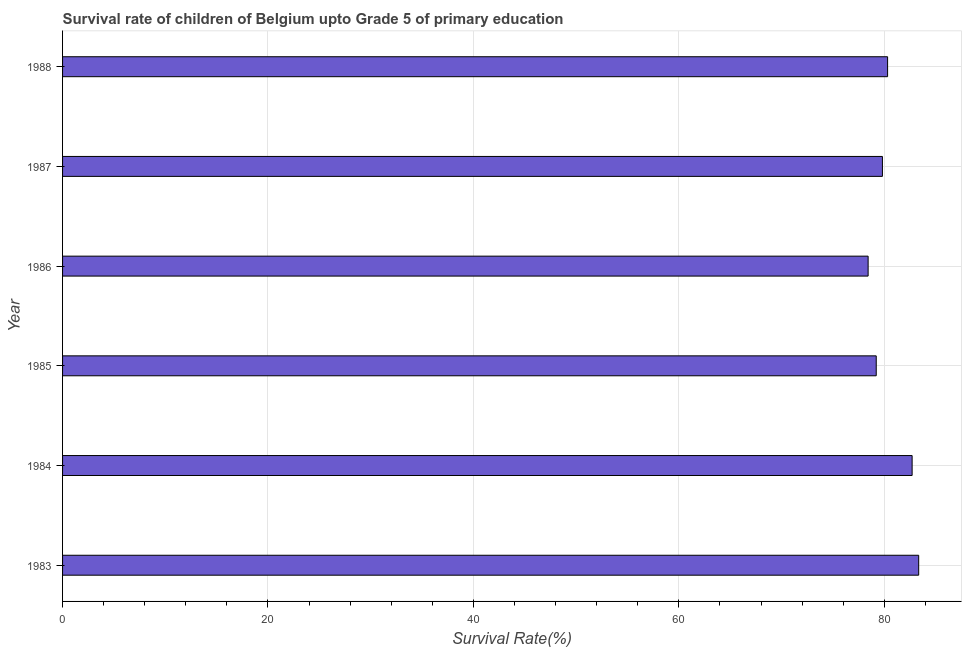Does the graph contain any zero values?
Keep it short and to the point. No. Does the graph contain grids?
Provide a short and direct response. Yes. What is the title of the graph?
Ensure brevity in your answer.  Survival rate of children of Belgium upto Grade 5 of primary education. What is the label or title of the X-axis?
Provide a short and direct response. Survival Rate(%). What is the label or title of the Y-axis?
Make the answer very short. Year. What is the survival rate in 1987?
Your answer should be compact. 79.82. Across all years, what is the maximum survival rate?
Your answer should be compact. 83.35. Across all years, what is the minimum survival rate?
Ensure brevity in your answer.  78.43. In which year was the survival rate minimum?
Provide a short and direct response. 1986. What is the sum of the survival rate?
Your response must be concise. 483.86. What is the difference between the survival rate in 1986 and 1987?
Offer a very short reply. -1.39. What is the average survival rate per year?
Make the answer very short. 80.64. What is the median survival rate?
Provide a short and direct response. 80.07. In how many years, is the survival rate greater than 48 %?
Keep it short and to the point. 6. Do a majority of the years between 1983 and 1988 (inclusive) have survival rate greater than 72 %?
Keep it short and to the point. Yes. What is the ratio of the survival rate in 1983 to that in 1987?
Offer a very short reply. 1.04. Is the survival rate in 1984 less than that in 1985?
Your response must be concise. No. Is the difference between the survival rate in 1983 and 1985 greater than the difference between any two years?
Your response must be concise. No. What is the difference between the highest and the second highest survival rate?
Offer a very short reply. 0.64. Is the sum of the survival rate in 1985 and 1988 greater than the maximum survival rate across all years?
Provide a short and direct response. Yes. What is the difference between the highest and the lowest survival rate?
Your answer should be compact. 4.92. In how many years, is the survival rate greater than the average survival rate taken over all years?
Provide a succinct answer. 2. Are all the bars in the graph horizontal?
Offer a terse response. Yes. What is the difference between two consecutive major ticks on the X-axis?
Provide a short and direct response. 20. What is the Survival Rate(%) of 1983?
Provide a succinct answer. 83.35. What is the Survival Rate(%) in 1984?
Ensure brevity in your answer.  82.71. What is the Survival Rate(%) in 1985?
Keep it short and to the point. 79.22. What is the Survival Rate(%) of 1986?
Offer a terse response. 78.43. What is the Survival Rate(%) of 1987?
Provide a succinct answer. 79.82. What is the Survival Rate(%) of 1988?
Offer a terse response. 80.32. What is the difference between the Survival Rate(%) in 1983 and 1984?
Provide a succinct answer. 0.64. What is the difference between the Survival Rate(%) in 1983 and 1985?
Offer a very short reply. 4.13. What is the difference between the Survival Rate(%) in 1983 and 1986?
Give a very brief answer. 4.92. What is the difference between the Survival Rate(%) in 1983 and 1987?
Make the answer very short. 3.53. What is the difference between the Survival Rate(%) in 1983 and 1988?
Provide a short and direct response. 3.03. What is the difference between the Survival Rate(%) in 1984 and 1985?
Provide a short and direct response. 3.49. What is the difference between the Survival Rate(%) in 1984 and 1986?
Ensure brevity in your answer.  4.28. What is the difference between the Survival Rate(%) in 1984 and 1987?
Ensure brevity in your answer.  2.89. What is the difference between the Survival Rate(%) in 1984 and 1988?
Offer a terse response. 2.39. What is the difference between the Survival Rate(%) in 1985 and 1986?
Provide a short and direct response. 0.79. What is the difference between the Survival Rate(%) in 1985 and 1987?
Give a very brief answer. -0.6. What is the difference between the Survival Rate(%) in 1985 and 1988?
Offer a very short reply. -1.11. What is the difference between the Survival Rate(%) in 1986 and 1987?
Keep it short and to the point. -1.39. What is the difference between the Survival Rate(%) in 1986 and 1988?
Keep it short and to the point. -1.9. What is the difference between the Survival Rate(%) in 1987 and 1988?
Make the answer very short. -0.5. What is the ratio of the Survival Rate(%) in 1983 to that in 1985?
Your answer should be very brief. 1.05. What is the ratio of the Survival Rate(%) in 1983 to that in 1986?
Make the answer very short. 1.06. What is the ratio of the Survival Rate(%) in 1983 to that in 1987?
Keep it short and to the point. 1.04. What is the ratio of the Survival Rate(%) in 1983 to that in 1988?
Make the answer very short. 1.04. What is the ratio of the Survival Rate(%) in 1984 to that in 1985?
Offer a terse response. 1.04. What is the ratio of the Survival Rate(%) in 1984 to that in 1986?
Your response must be concise. 1.05. What is the ratio of the Survival Rate(%) in 1984 to that in 1987?
Offer a terse response. 1.04. What is the ratio of the Survival Rate(%) in 1984 to that in 1988?
Make the answer very short. 1.03. 